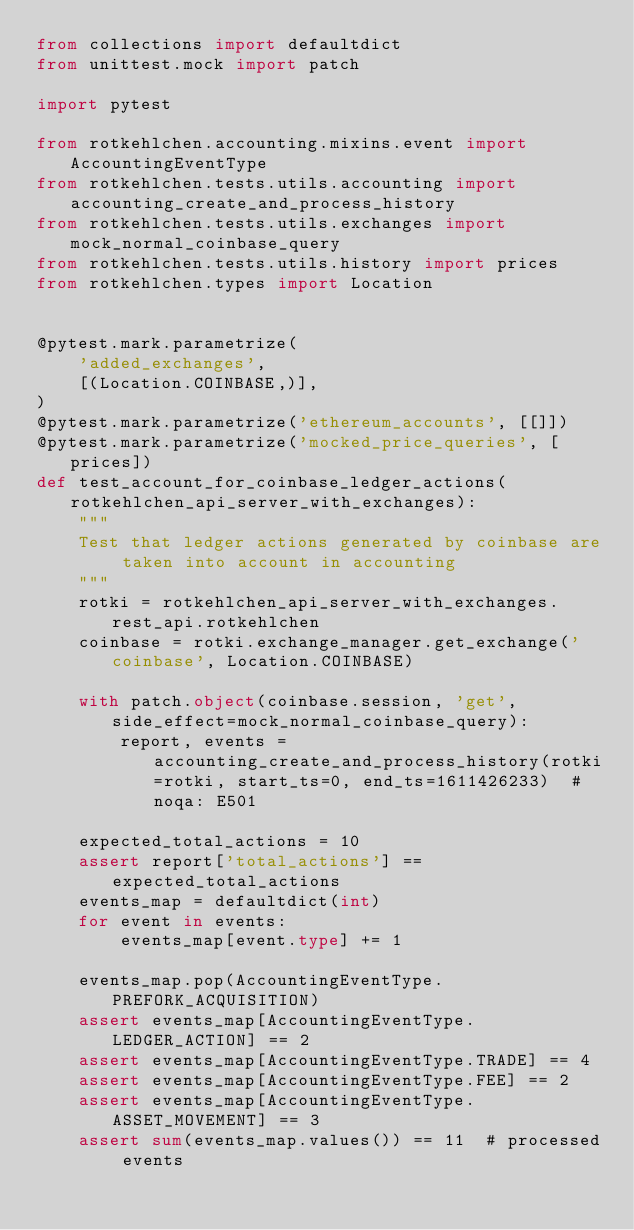<code> <loc_0><loc_0><loc_500><loc_500><_Python_>from collections import defaultdict
from unittest.mock import patch

import pytest

from rotkehlchen.accounting.mixins.event import AccountingEventType
from rotkehlchen.tests.utils.accounting import accounting_create_and_process_history
from rotkehlchen.tests.utils.exchanges import mock_normal_coinbase_query
from rotkehlchen.tests.utils.history import prices
from rotkehlchen.types import Location


@pytest.mark.parametrize(
    'added_exchanges',
    [(Location.COINBASE,)],
)
@pytest.mark.parametrize('ethereum_accounts', [[]])
@pytest.mark.parametrize('mocked_price_queries', [prices])
def test_account_for_coinbase_ledger_actions(rotkehlchen_api_server_with_exchanges):
    """
    Test that ledger actions generated by coinbase are taken into account in accounting
    """
    rotki = rotkehlchen_api_server_with_exchanges.rest_api.rotkehlchen
    coinbase = rotki.exchange_manager.get_exchange('coinbase', Location.COINBASE)

    with patch.object(coinbase.session, 'get', side_effect=mock_normal_coinbase_query):
        report, events = accounting_create_and_process_history(rotki=rotki, start_ts=0, end_ts=1611426233)  # noqa: E501

    expected_total_actions = 10
    assert report['total_actions'] == expected_total_actions
    events_map = defaultdict(int)
    for event in events:
        events_map[event.type] += 1

    events_map.pop(AccountingEventType.PREFORK_ACQUISITION)
    assert events_map[AccountingEventType.LEDGER_ACTION] == 2
    assert events_map[AccountingEventType.TRADE] == 4
    assert events_map[AccountingEventType.FEE] == 2
    assert events_map[AccountingEventType.ASSET_MOVEMENT] == 3
    assert sum(events_map.values()) == 11  # processed events
</code> 